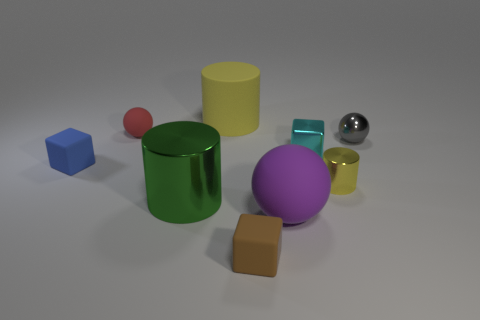Subtract all tiny rubber cubes. How many cubes are left? 1 Add 1 red matte blocks. How many objects exist? 10 Subtract all red blocks. How many yellow cylinders are left? 2 Subtract all blocks. How many objects are left? 6 Subtract 3 cylinders. How many cylinders are left? 0 Subtract all purple cylinders. Subtract all red balls. How many cylinders are left? 3 Subtract all small cyan metal things. Subtract all brown cubes. How many objects are left? 7 Add 8 yellow rubber cylinders. How many yellow rubber cylinders are left? 9 Add 4 small cyan cubes. How many small cyan cubes exist? 5 Subtract 0 cyan cylinders. How many objects are left? 9 